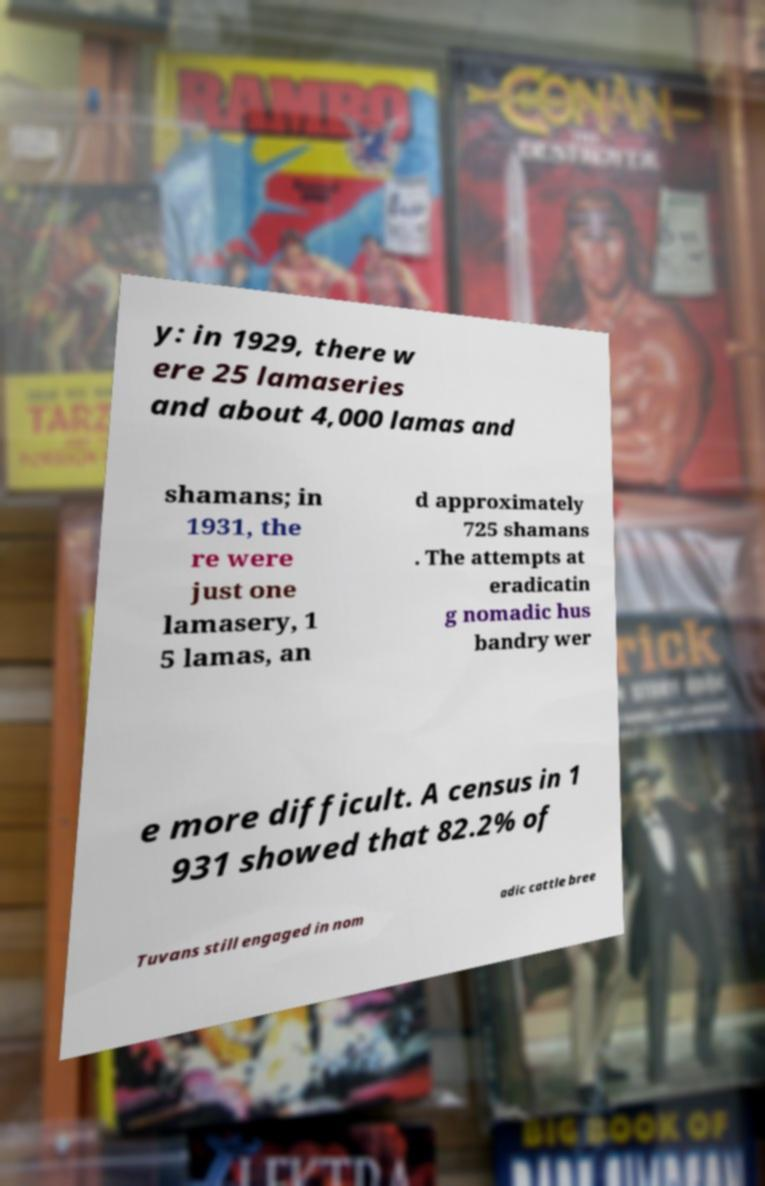Could you assist in decoding the text presented in this image and type it out clearly? y: in 1929, there w ere 25 lamaseries and about 4,000 lamas and shamans; in 1931, the re were just one lamasery, 1 5 lamas, an d approximately 725 shamans . The attempts at eradicatin g nomadic hus bandry wer e more difficult. A census in 1 931 showed that 82.2% of Tuvans still engaged in nom adic cattle bree 